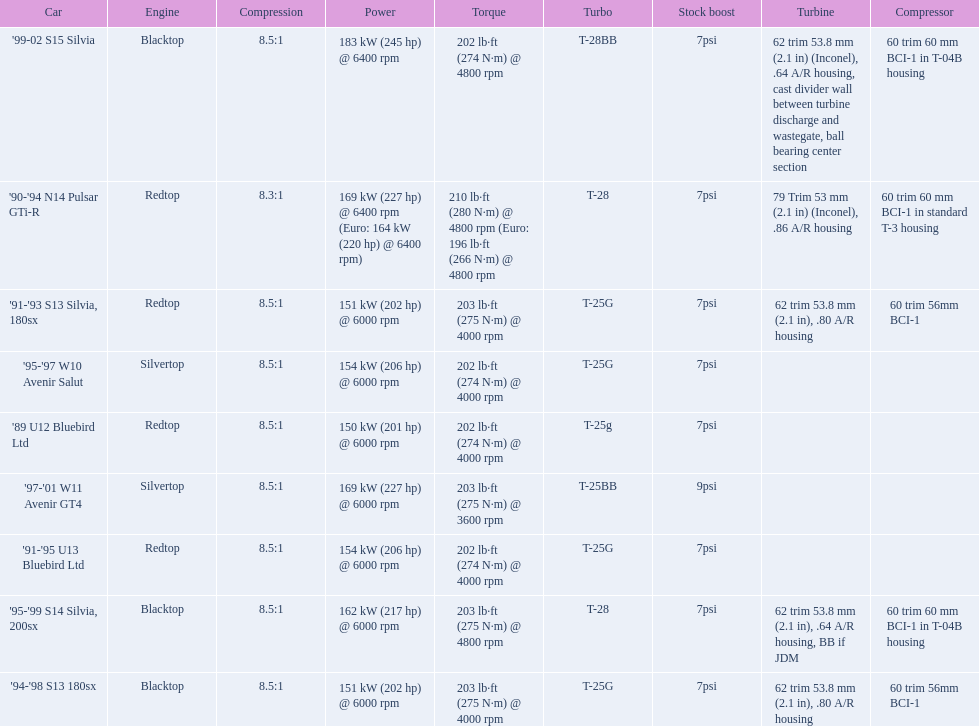Which cars featured blacktop engines? '94-'98 S13 180sx, '95-'99 S14 Silvia, 200sx, '99-02 S15 Silvia. Which of these had t-04b compressor housings? '95-'99 S14 Silvia, 200sx, '99-02 S15 Silvia. Which one of these has the highest horsepower? '99-02 S15 Silvia. 